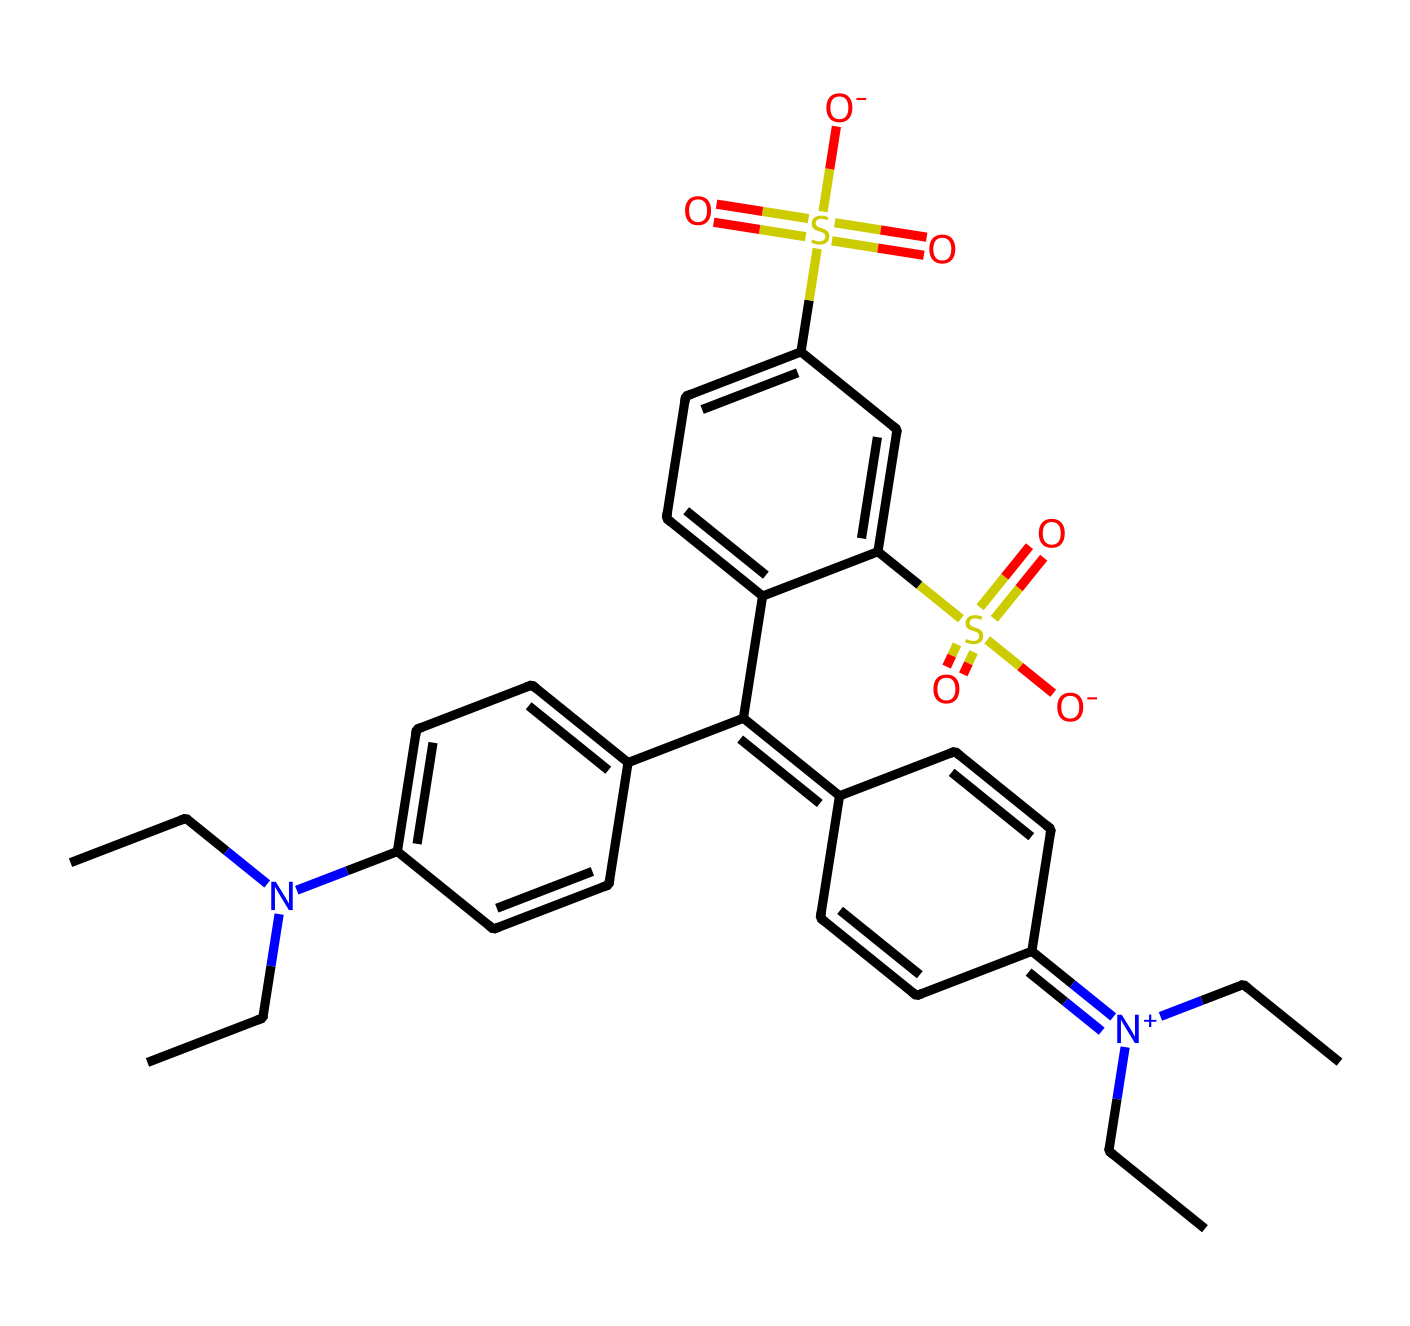What is the main functional group in this dye? The structure contains sulfonic acid groups, indicated by the -S(=O)(=O)[O-] sections, which are typical in dyes for solubility in water.
Answer: sulfonic acid How many carbon atoms are present in the molecule? By analyzing the SMILES representation, the total number of 'C' characters indicates 23 carbon atoms present in the structure.
Answer: 23 What type of bonding is predominantly seen in this chemical structure? The structure features a significant amount of carbon-carbon (C-C) and carbon-nitrogen (C-N) single bonds, along with some double bonds between carbon atoms.
Answer: single and double bonds What is the charge of the nitrogen atoms in this dye? The nitrogen atoms in the structure are positively charged, denoted by the [N+] in the representation, suggesting they are part of a quaternary ammonium ion.
Answer: positive What can you infer about the solubility of this dye in water? The presence of sulfonic acid groups typically increases solubility in water due to their ionic nature, allowing for greater interaction with water molecules.
Answer: soluble How many aromatic rings are visible in the structure? The structure contains three distinct benzene rings, identifiable by the alternating double bonds in the cyclic structures.
Answer: three 